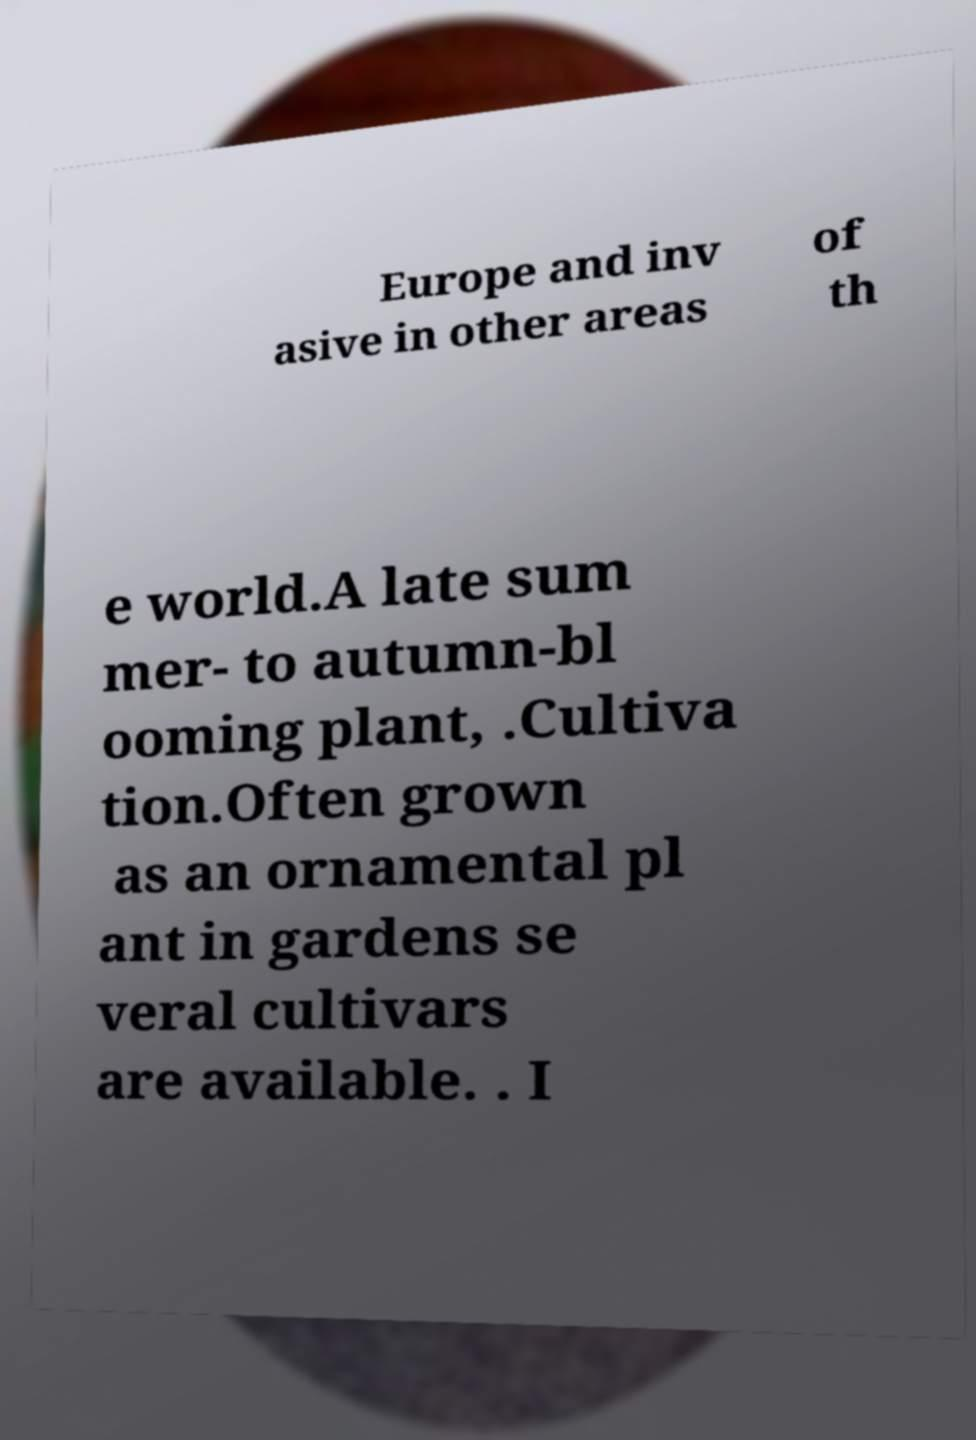For documentation purposes, I need the text within this image transcribed. Could you provide that? Europe and inv asive in other areas of th e world.A late sum mer- to autumn-bl ooming plant, .Cultiva tion.Often grown as an ornamental pl ant in gardens se veral cultivars are available. . I 